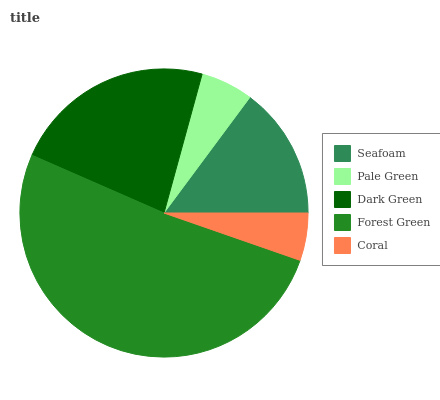Is Coral the minimum?
Answer yes or no. Yes. Is Forest Green the maximum?
Answer yes or no. Yes. Is Pale Green the minimum?
Answer yes or no. No. Is Pale Green the maximum?
Answer yes or no. No. Is Seafoam greater than Pale Green?
Answer yes or no. Yes. Is Pale Green less than Seafoam?
Answer yes or no. Yes. Is Pale Green greater than Seafoam?
Answer yes or no. No. Is Seafoam less than Pale Green?
Answer yes or no. No. Is Seafoam the high median?
Answer yes or no. Yes. Is Seafoam the low median?
Answer yes or no. Yes. Is Coral the high median?
Answer yes or no. No. Is Dark Green the low median?
Answer yes or no. No. 